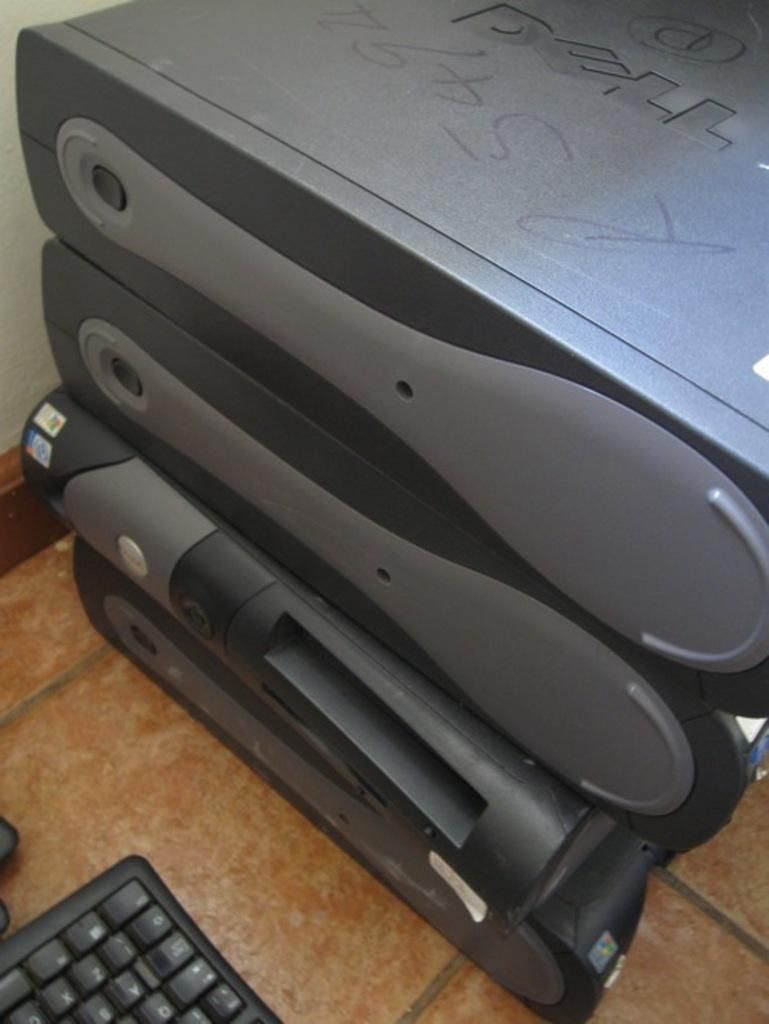<image>
Offer a succinct explanation of the picture presented. Stacked computer hardware including at least one from DELL. 